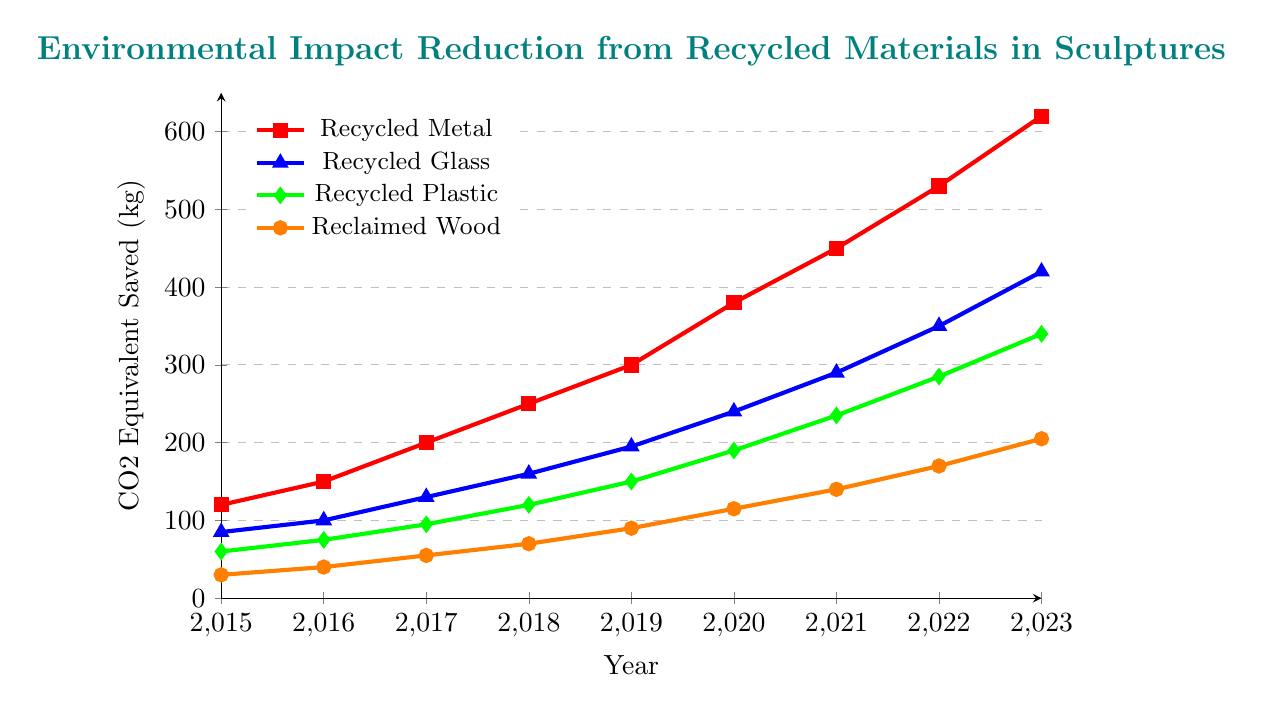Which material saved the most CO2 equivalent in 2023? Look at the y-values for the year 2023 for each material and identify the highest value. Recycled Metal saved 620 kg CO2e, which is the most.
Answer: Recycled Metal How much CO2 equivalent was saved by using Recycled Glass and Reclaimed Wood in 2020 combined? Find the y-values for Recycled Glass and Reclaimed Wood in 2020 and sum them up. Recycled Glass saved 240 kg CO2e, and Reclaimed Wood saved 115 kg CO2e. Combined, they saved 240 + 115 = 355 kg CO2e.
Answer: 355 kg CO2e Which material had the least CO2 equivalent savings in 2017? Look at the y-values for the year 2017 and find the smallest value. Reclaimed Wood saved 55 kg CO2e, which is the least.
Answer: Reclaimed Wood Between which two consecutive years did Recycled Metal see the largest increase in CO2 equivalent savings? Calculate the increase in CO2 equivalent savings for Recycled Metal between each pair of consecutive years and find the largest difference. The increases are 30 kg (2015-2016), 50 kg (2016-2017), 50 kg (2017-2018), 50 kg (2018-2019), 80 kg (2019-2020), 70 kg (2020-2021), 80 kg (2021-2022), and 90 kg (2022-2023). The largest increase is from 2022 to 2023 with 90 kg.
Answer: 2022 to 2023 In which year did Reclaimed Wood exceed 100 kg CO2 equivalent savings for the first time? Find the year when the y-values for Reclaimed Wood first exceeded 100 kg. In 2020, Reclaimed Wood saved 115 kg CO2e, which is the first time it exceeded 100 kg.
Answer: 2020 Which material has shown a consistent increase in CO2 equivalent savings every year from 2015 to 2023? Check each material's y-values year by year to see if there is a consistent increase each year. All four materials have shown a consistent increase every year.
Answer: All four materials By how much did the CO2 equivalent savings from Recycled Plastic increase from 2019 to 2023? Find the y-values for Recycled Plastic in 2019 and 2023, then calculate the difference. In 2019, Recycled Plastic saved 150 kg CO2e; in 2023, it saved 340 kg CO2e. The increase is 340 - 150 = 190 kg CO2e.
Answer: 190 kg CO2e Which color represents the material with the least CO2 equivalent savings in 2015? Check the colors associated with each material and match the color with the material that saved the least CO2 equivalent in 2015. Reclaimed Wood is represented by orange and saved the least CO2 equivalent (30 kg CO2e) in 2015.
Answer: orange What was the total CO2 equivalent saved by all materials combined in 2018? Add the y-values for all materials in 2018. For 2018: Recycled Metal (250 kg) + Recycled Glass (160 kg) + Recycled Plastic (120 kg) + Reclaimed Wood (70 kg) = 600 kg CO2e.
Answer: 600 kg CO2e True or False: Recycled Plastic saved less CO2 equivalent than Recycled Glass every year from 2015 to 2023. Compare the y-values for Recycled Plastic and Recycled Glass for each year and verify if the statement holds true. Recycled Glass consistently saved more CO2 equivalent than Recycled Plastic every year.
Answer: True 